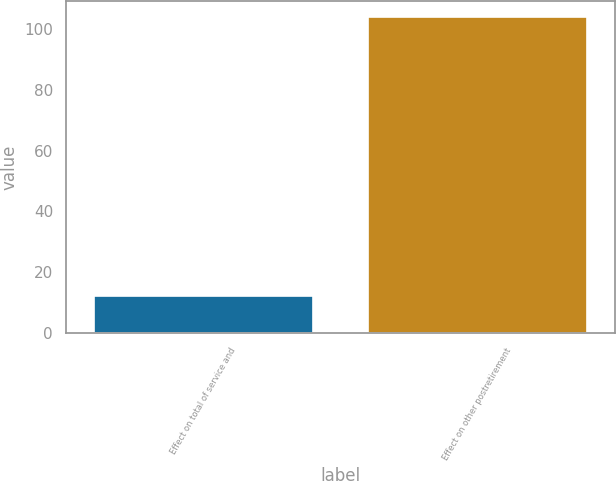Convert chart. <chart><loc_0><loc_0><loc_500><loc_500><bar_chart><fcel>Effect on total of service and<fcel>Effect on other postretirement<nl><fcel>12<fcel>104<nl></chart> 